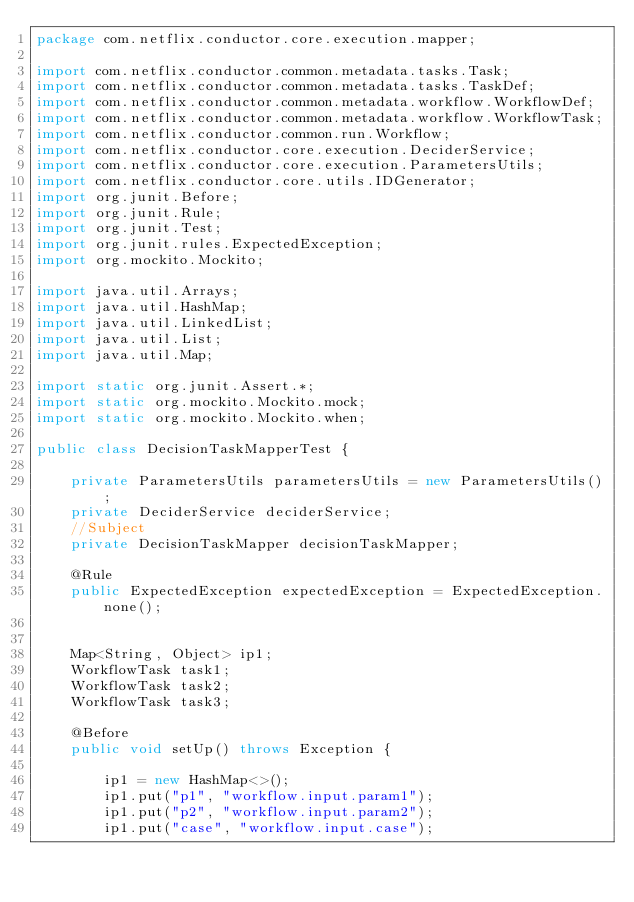<code> <loc_0><loc_0><loc_500><loc_500><_Java_>package com.netflix.conductor.core.execution.mapper;

import com.netflix.conductor.common.metadata.tasks.Task;
import com.netflix.conductor.common.metadata.tasks.TaskDef;
import com.netflix.conductor.common.metadata.workflow.WorkflowDef;
import com.netflix.conductor.common.metadata.workflow.WorkflowTask;
import com.netflix.conductor.common.run.Workflow;
import com.netflix.conductor.core.execution.DeciderService;
import com.netflix.conductor.core.execution.ParametersUtils;
import com.netflix.conductor.core.utils.IDGenerator;
import org.junit.Before;
import org.junit.Rule;
import org.junit.Test;
import org.junit.rules.ExpectedException;
import org.mockito.Mockito;

import java.util.Arrays;
import java.util.HashMap;
import java.util.LinkedList;
import java.util.List;
import java.util.Map;

import static org.junit.Assert.*;
import static org.mockito.Mockito.mock;
import static org.mockito.Mockito.when;

public class DecisionTaskMapperTest {

    private ParametersUtils parametersUtils = new ParametersUtils();
    private DeciderService deciderService;
    //Subject
    private DecisionTaskMapper decisionTaskMapper;

    @Rule
    public ExpectedException expectedException = ExpectedException.none();


    Map<String, Object> ip1;
    WorkflowTask task1;
    WorkflowTask task2;
    WorkflowTask task3;

    @Before
    public void setUp() throws Exception {

        ip1 = new HashMap<>();
        ip1.put("p1", "workflow.input.param1");
        ip1.put("p2", "workflow.input.param2");
        ip1.put("case", "workflow.input.case");
</code> 